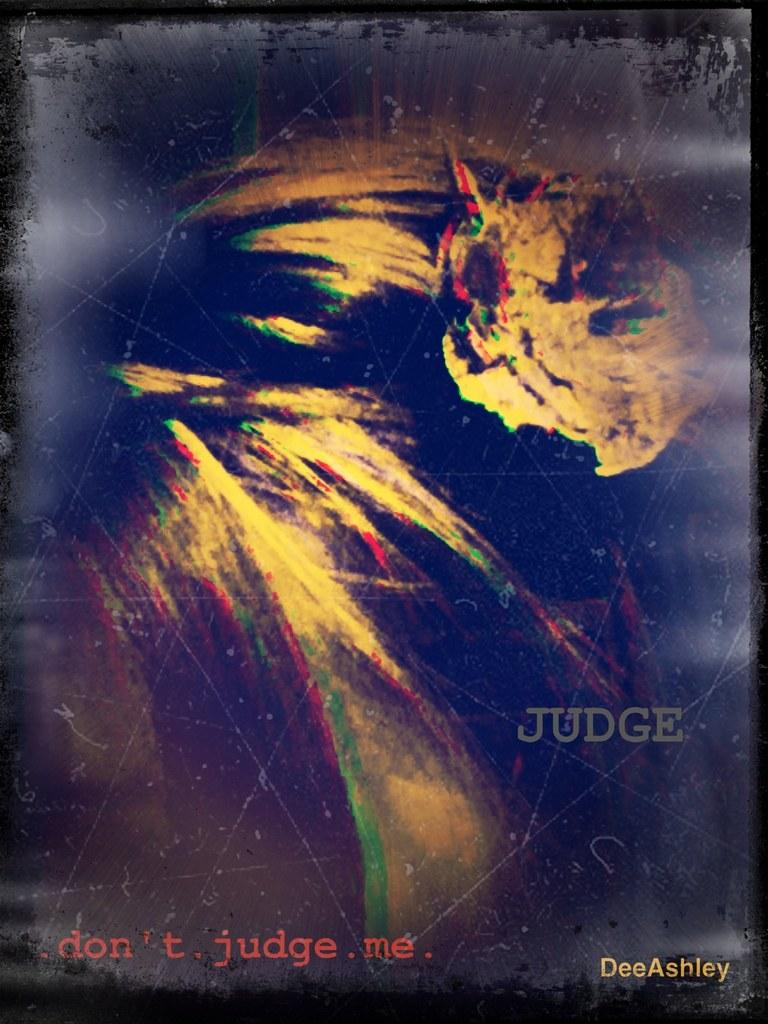<image>
Offer a succinct explanation of the picture presented. Artwork that has the word JUDGE on the bottom in gray. 